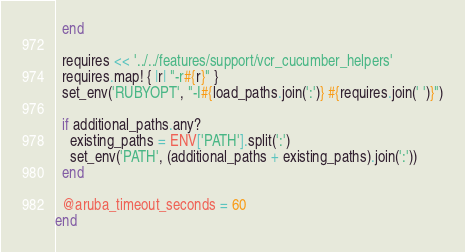Convert code to text. <code><loc_0><loc_0><loc_500><loc_500><_Ruby_>  end

  requires << '../../features/support/vcr_cucumber_helpers'
  requires.map! { |r| "-r#{r}" }
  set_env('RUBYOPT', "-I#{load_paths.join(':')} #{requires.join(' ')}")

  if additional_paths.any?
    existing_paths = ENV['PATH'].split(':')
    set_env('PATH', (additional_paths + existing_paths).join(':'))
  end

  @aruba_timeout_seconds = 60
end

</code> 